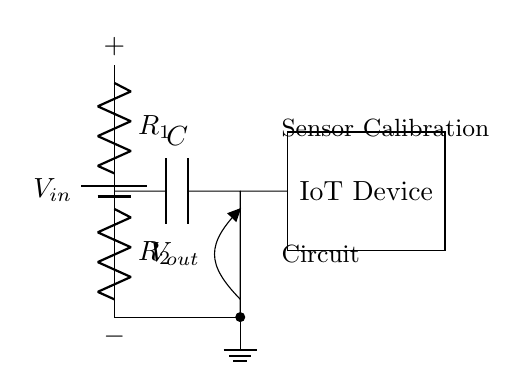What is the input voltage in this circuit? The input voltage is indicated as \(V_{in}\) at the top of the circuit. It is the potential supplied by the battery.
Answer: \(V_{in}\) What are the values of the resistors in this voltage divider? The circuit diagram labels two resistors: \(R_1\) and \(R_2\); however, no specific numerical values are provided in this diagram.
Answer: \(R_1, R_2\) What does the capacitor do in this circuit? The capacitor \(C\) stores charge and smooths variations in the output voltage \(V_{out}\), making it essential for stable sensor calibration in IoT devices.
Answer: Smooths voltage Where is the output voltage measured in this circuit? The output voltage \(V_{out}\) is measured at the junction between the capacitor and the resistor divider, indicated by the label at that point in the circuit.
Answer: At the capacitor How does the capacitor affect the time constant in this circuit? The time constant \(\tau\) for an RC circuit is given by \(\tau = R \times C\). In this case, \(R\) can be considered as the equivalent resistance of the resistors, affecting the charging and discharging time of the capacitor.
Answer: Affects time constant What is the purpose of the ground in this circuit? The ground provides a common reference point for all voltages in the circuit, ensuring stable operation and accurate voltage readings in relation to \(V_{out}\).
Answer: Common reference What happens if \(R_1\) is much larger than \(R_2\)? If \(R_1\) is much larger than \(R_2\), the output voltage \(V_{out}\) will be closer to zero because the voltage drop across \(R_1\) will dominate the voltage divider, resulting in lower voltage to the sensor.
Answer: \(V_{out} \approx 0\) 